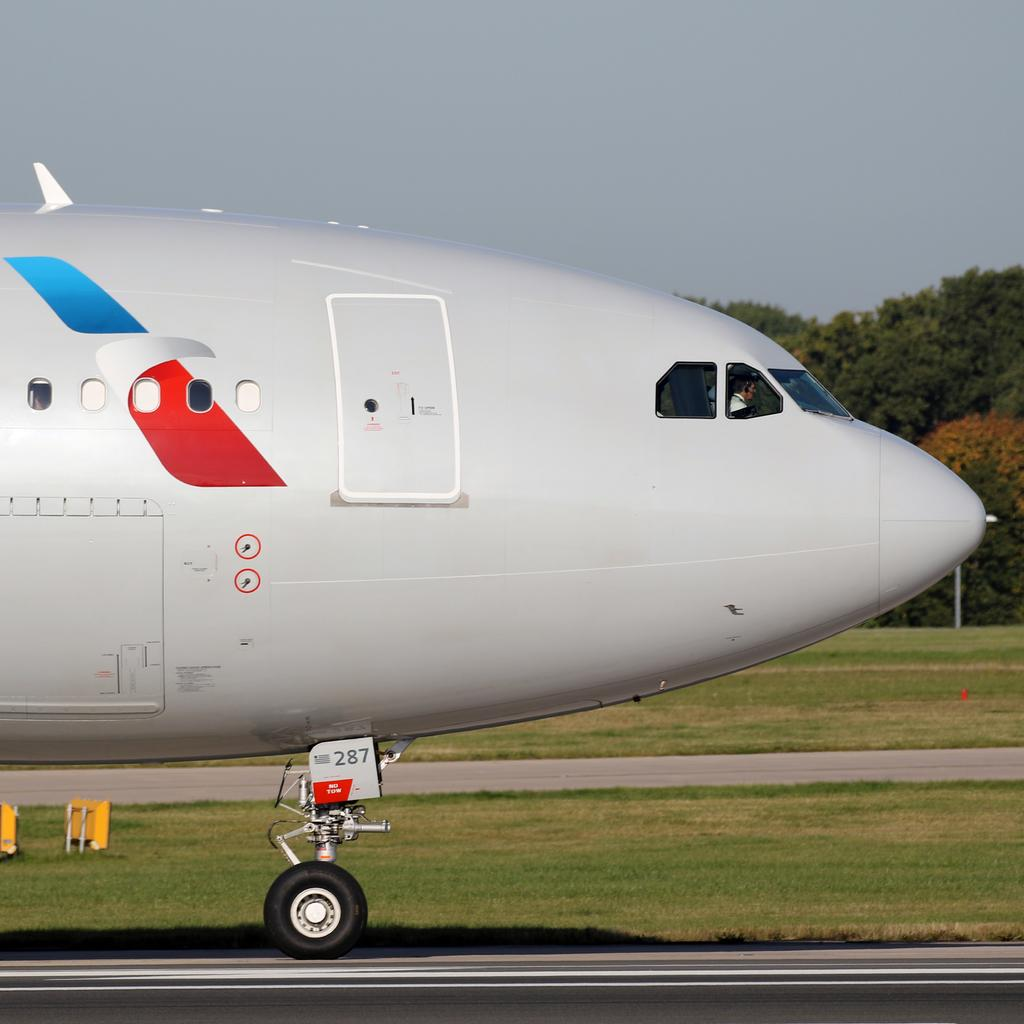What is the main subject of the picture? The main subject of the picture is an airplane. Can you describe the person inside the airplane? A person is seated in the airplane. What can be seen in the background of the image? There is grass, trees, and a pole visible in the background of the image. What type of cloth is draped over the throne in the image? There is no throne present in the image; it features an airplane with a person seated inside. How many journeys has the cloth on the throne been on? There is no cloth or throne present in the image, so it's not possible to determine the number of journeys the cloth has been on. 